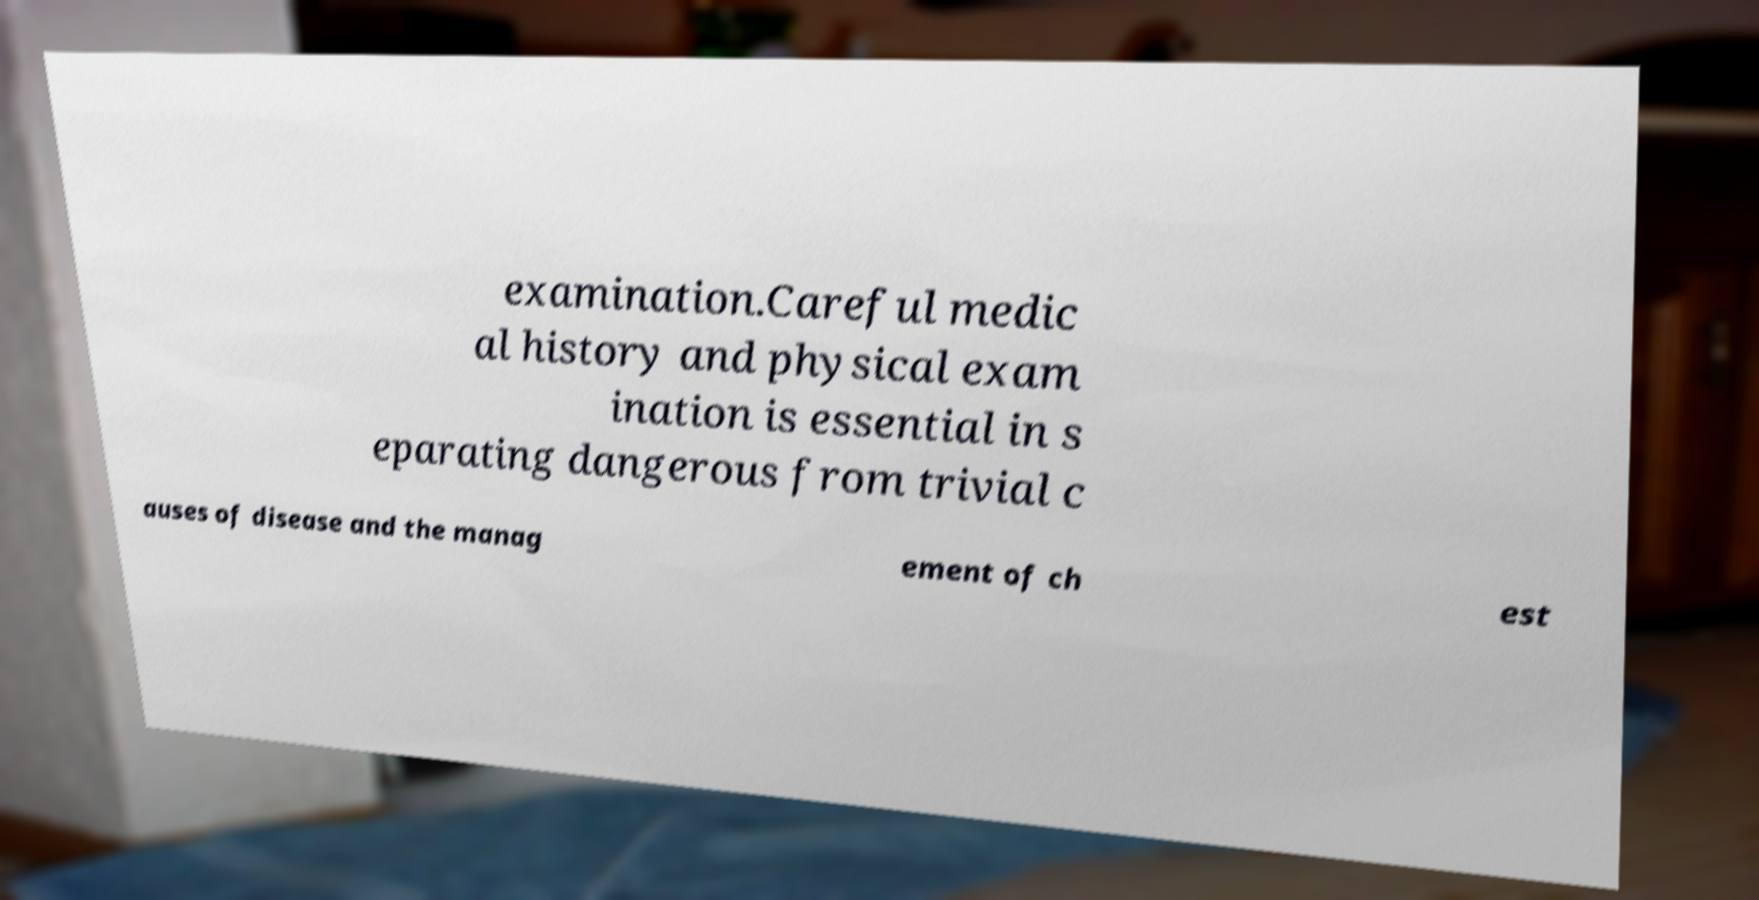For documentation purposes, I need the text within this image transcribed. Could you provide that? examination.Careful medic al history and physical exam ination is essential in s eparating dangerous from trivial c auses of disease and the manag ement of ch est 